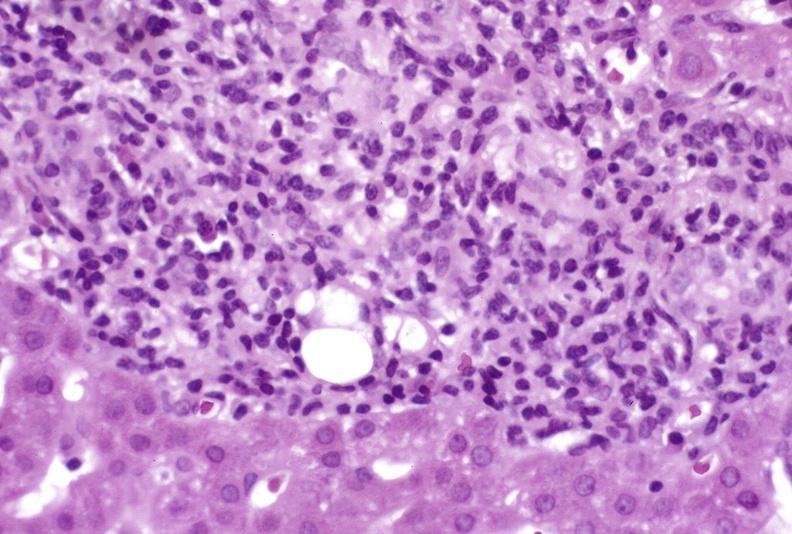s metastatic carcinoma lung present?
Answer the question using a single word or phrase. No 